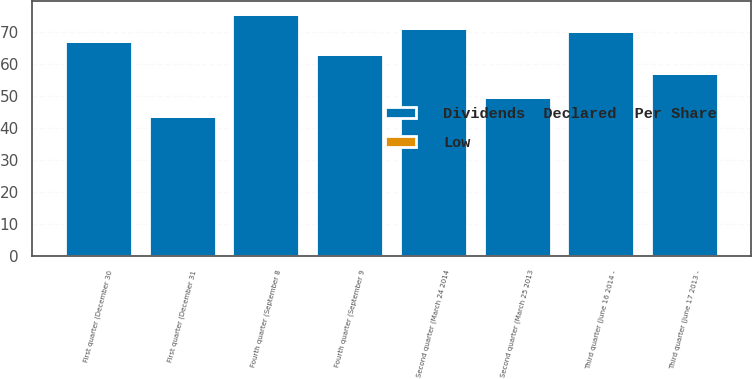<chart> <loc_0><loc_0><loc_500><loc_500><stacked_bar_chart><ecel><fcel>First quarter (December 31<fcel>Second quarter (March 25 2013<fcel>Third quarter (June 17 2013 -<fcel>Fourth quarter (September 9<fcel>First quarter (December 30<fcel>Second quarter (March 24 2014<fcel>Third quarter (June 16 2014 -<fcel>Fourth quarter (September 8<nl><fcel>Dividends  Declared  Per Share<fcel>43.55<fcel>49.65<fcel>57.01<fcel>63.04<fcel>67.17<fcel>71.13<fcel>70.17<fcel>75.54<nl><fcel>Low<fcel>0.2<fcel>0.2<fcel>0.2<fcel>0.2<fcel>0.25<fcel>0.25<fcel>0.25<fcel>0.25<nl></chart> 